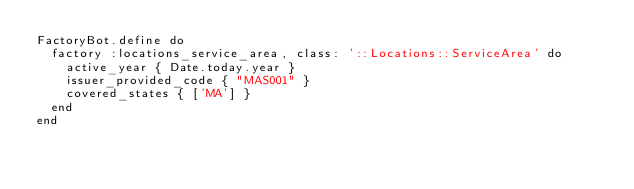Convert code to text. <code><loc_0><loc_0><loc_500><loc_500><_Ruby_>FactoryBot.define do
  factory :locations_service_area, class: '::Locations::ServiceArea' do
    active_year { Date.today.year }
    issuer_provided_code { "MAS001" }
    covered_states { ['MA'] }
  end
end
</code> 